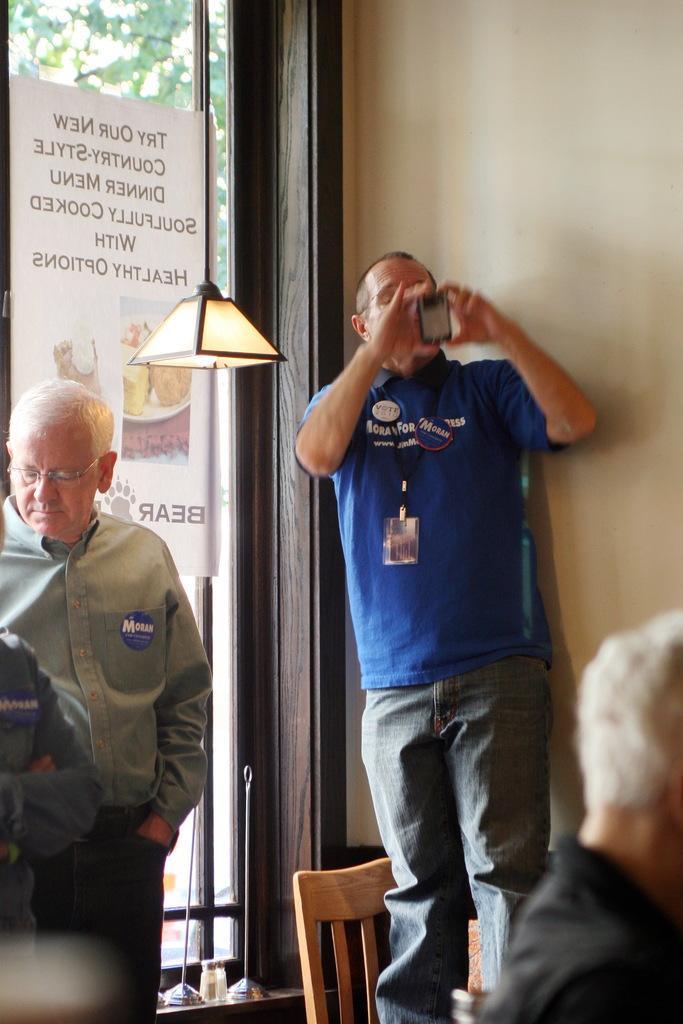Could you give a brief overview of what you see in this image? The person wearing blue shirt is standing on a chair and clicking a picture and there is a another person standing beside him. 